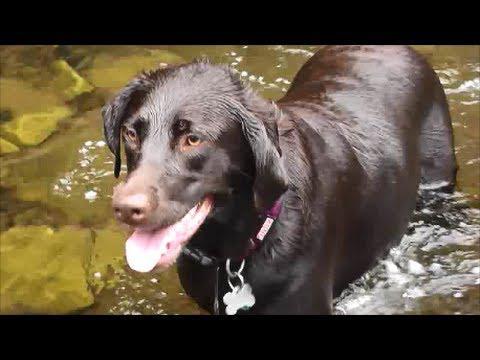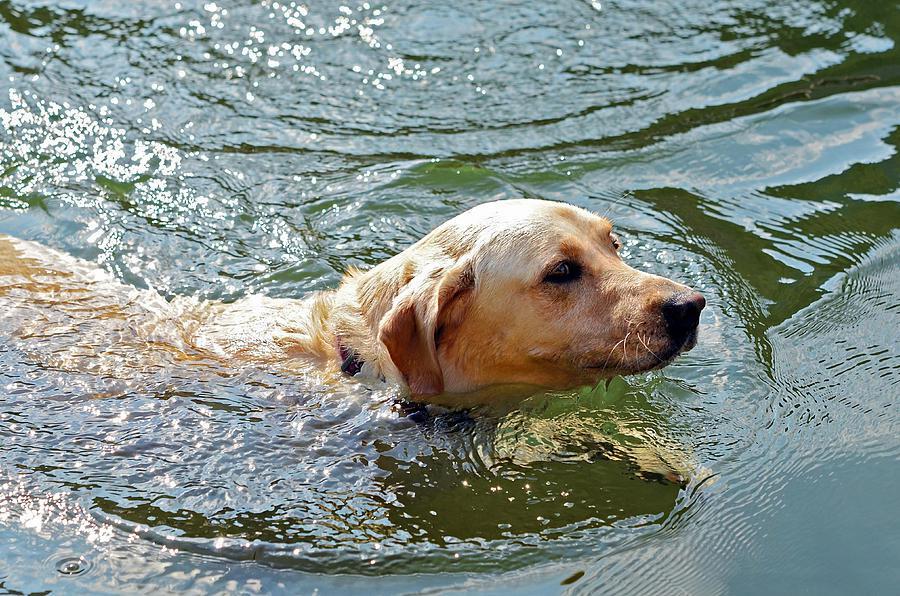The first image is the image on the left, the second image is the image on the right. Given the left and right images, does the statement "a dog is swimming while carrying something in it's mouth" hold true? Answer yes or no. No. The first image is the image on the left, the second image is the image on the right. Analyze the images presented: Is the assertion "One dog has something in its mouth." valid? Answer yes or no. No. 